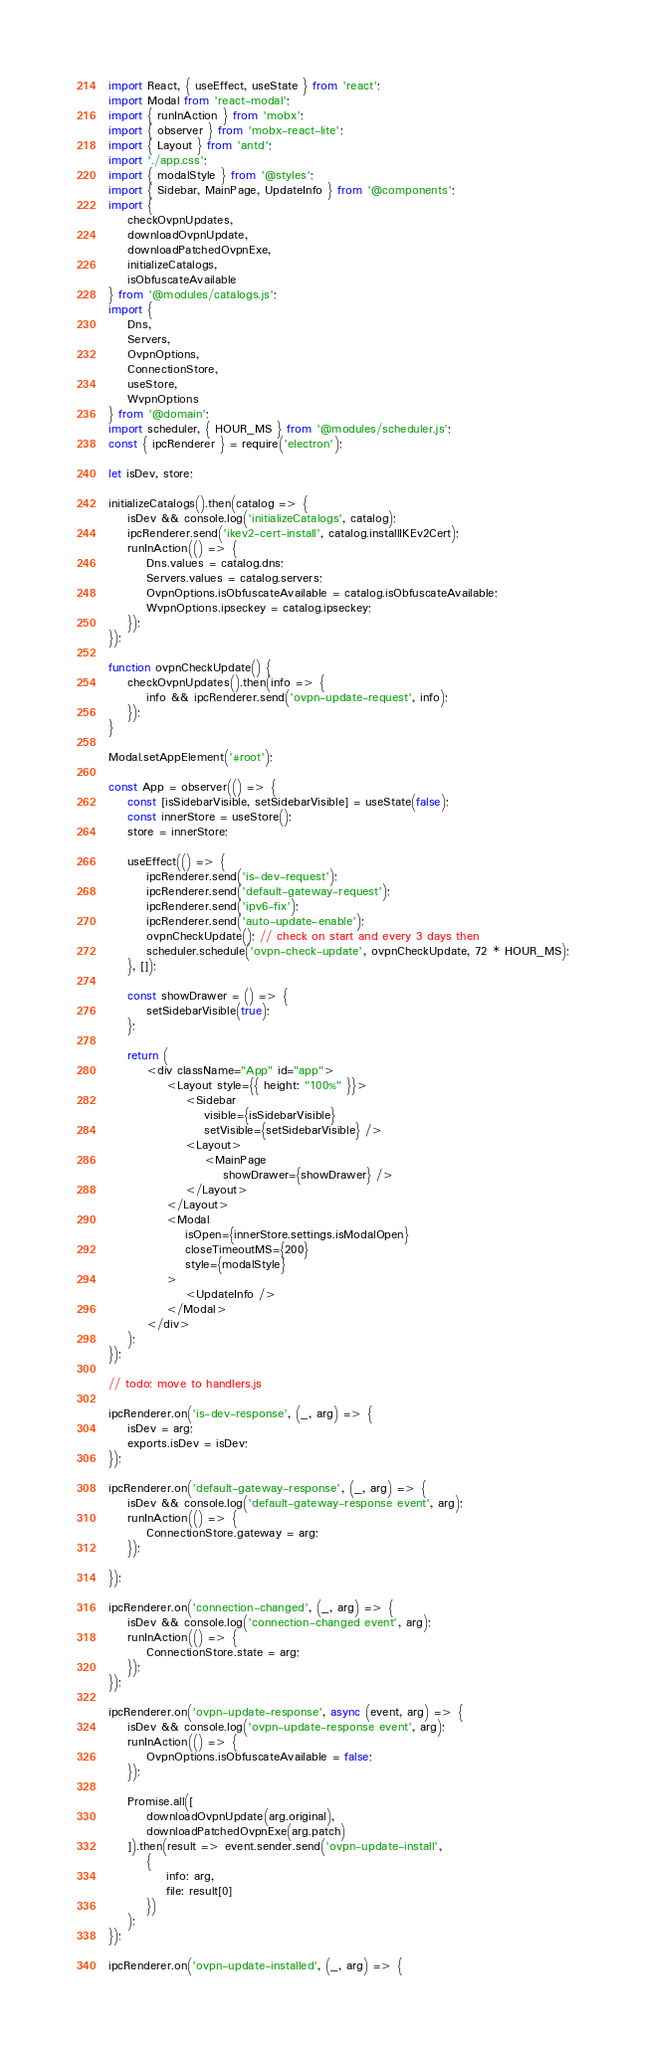<code> <loc_0><loc_0><loc_500><loc_500><_JavaScript_>import React, { useEffect, useState } from 'react';
import Modal from 'react-modal';
import { runInAction } from 'mobx';
import { observer } from 'mobx-react-lite';
import { Layout } from 'antd';
import './app.css';
import { modalStyle } from '@styles';
import { Sidebar, MainPage, UpdateInfo } from '@components';
import {
    checkOvpnUpdates,
    downloadOvpnUpdate,
    downloadPatchedOvpnExe,
    initializeCatalogs,
    isObfuscateAvailable
} from '@modules/catalogs.js';
import {
    Dns,
    Servers,
    OvpnOptions,
    ConnectionStore,
    useStore,
    WvpnOptions
} from '@domain';
import scheduler, { HOUR_MS } from '@modules/scheduler.js';
const { ipcRenderer } = require('electron');

let isDev, store;

initializeCatalogs().then(catalog => {
    isDev && console.log('initializeCatalogs', catalog);
    ipcRenderer.send('ikev2-cert-install', catalog.installIKEv2Cert);
    runInAction(() => {
        Dns.values = catalog.dns;
        Servers.values = catalog.servers;
        OvpnOptions.isObfuscateAvailable = catalog.isObfuscateAvailable;
        WvpnOptions.ipseckey = catalog.ipseckey;
    });
});

function ovpnCheckUpdate() {
    checkOvpnUpdates().then(info => {
        info && ipcRenderer.send('ovpn-update-request', info);
    });
}

Modal.setAppElement('#root');

const App = observer(() => {
    const [isSidebarVisible, setSidebarVisible] = useState(false);
    const innerStore = useStore();
    store = innerStore;

    useEffect(() => {
        ipcRenderer.send('is-dev-request');
        ipcRenderer.send('default-gateway-request');
        ipcRenderer.send('ipv6-fix');
        ipcRenderer.send('auto-update-enable');
        ovpnCheckUpdate(); // check on start and every 3 days then
        scheduler.schedule('ovpn-check-update', ovpnCheckUpdate, 72 * HOUR_MS);
    }, []);

    const showDrawer = () => {
        setSidebarVisible(true);
    };

    return (
        <div className="App" id="app">
            <Layout style={{ height: "100%" }}>
                <Sidebar
                    visible={isSidebarVisible}
                    setVisible={setSidebarVisible} />
                <Layout>
                    <MainPage
                        showDrawer={showDrawer} />
                </Layout>
            </Layout>
            <Modal
                isOpen={innerStore.settings.isModalOpen}
                closeTimeoutMS={200}
                style={modalStyle}
            >
                <UpdateInfo />
            </Modal>
        </div>
    );
});

// todo: move to handlers.js

ipcRenderer.on('is-dev-response', (_, arg) => {
    isDev = arg;
    exports.isDev = isDev;
});

ipcRenderer.on('default-gateway-response', (_, arg) => {
    isDev && console.log('default-gateway-response event', arg);
    runInAction(() => {
        ConnectionStore.gateway = arg;
    });

});

ipcRenderer.on('connection-changed', (_, arg) => {
    isDev && console.log('connection-changed event', arg);
    runInAction(() => {
        ConnectionStore.state = arg;
    });
});

ipcRenderer.on('ovpn-update-response', async (event, arg) => {
    isDev && console.log('ovpn-update-response event', arg);
    runInAction(() => {
        OvpnOptions.isObfuscateAvailable = false;
    });

    Promise.all([
        downloadOvpnUpdate(arg.original),
        downloadPatchedOvpnExe(arg.patch)
    ]).then(result => event.sender.send('ovpn-update-install',
        {
            info: arg,
            file: result[0]
        })
    );
});

ipcRenderer.on('ovpn-update-installed', (_, arg) => {</code> 